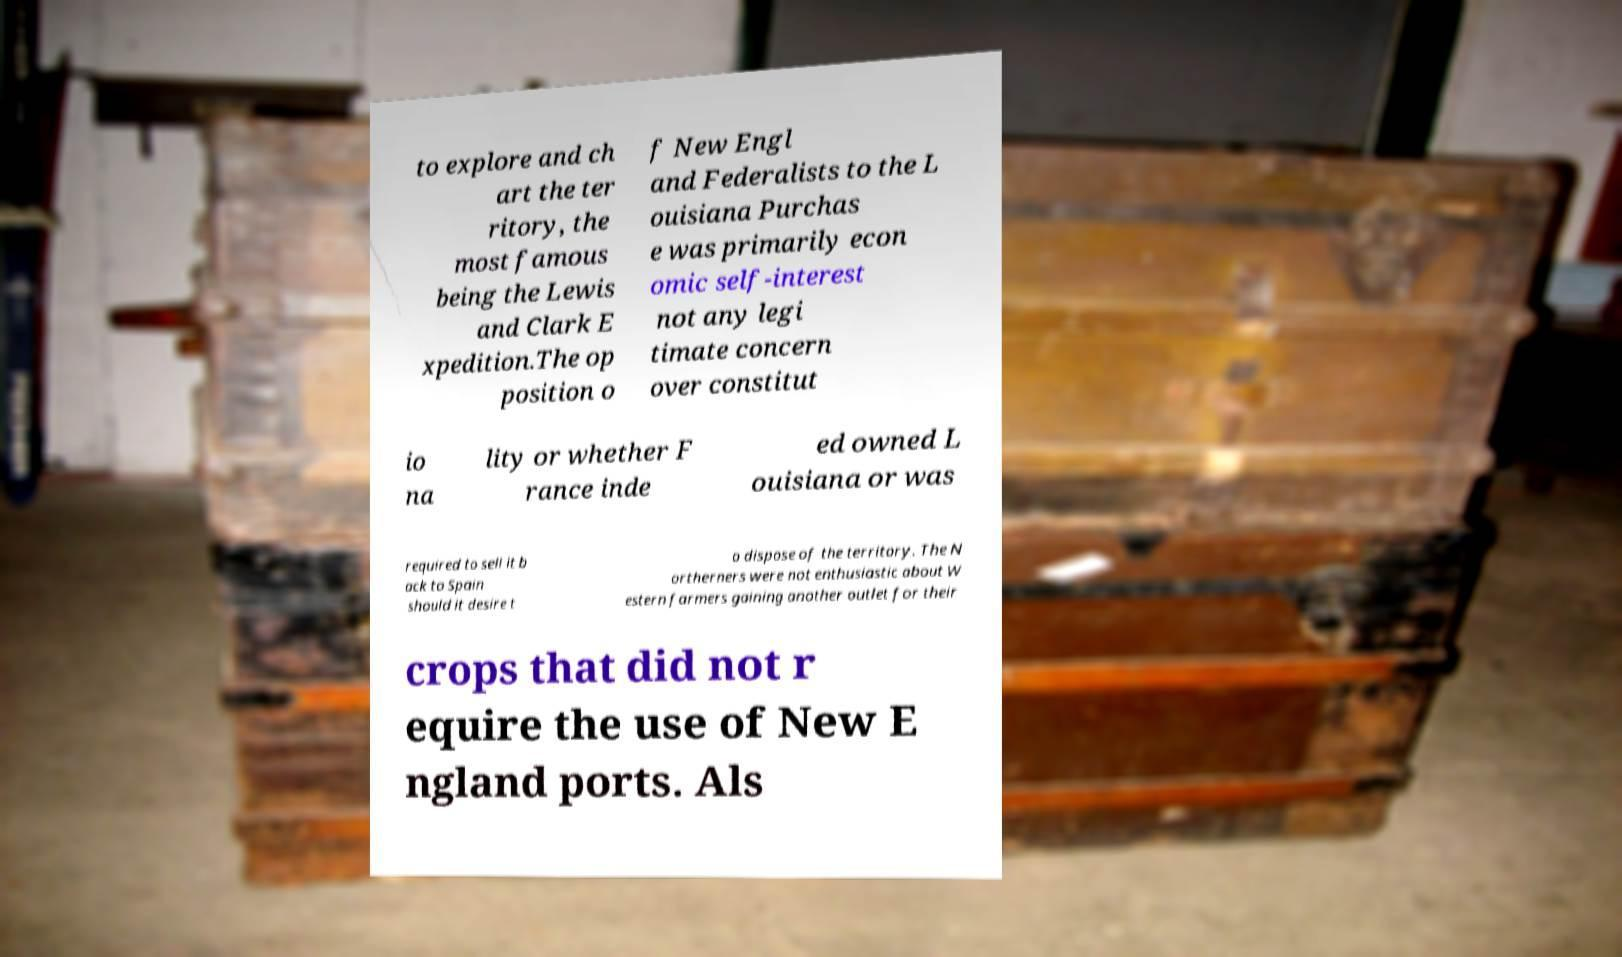Can you read and provide the text displayed in the image?This photo seems to have some interesting text. Can you extract and type it out for me? to explore and ch art the ter ritory, the most famous being the Lewis and Clark E xpedition.The op position o f New Engl and Federalists to the L ouisiana Purchas e was primarily econ omic self-interest not any legi timate concern over constitut io na lity or whether F rance inde ed owned L ouisiana or was required to sell it b ack to Spain should it desire t o dispose of the territory. The N ortherners were not enthusiastic about W estern farmers gaining another outlet for their crops that did not r equire the use of New E ngland ports. Als 